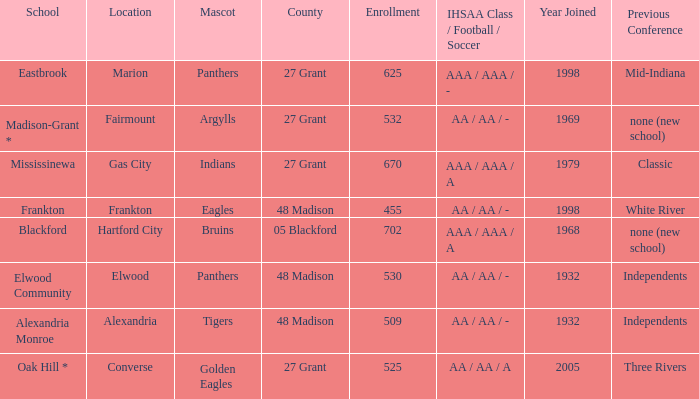What is teh ihsaa class/football/soccer when the location is alexandria? AA / AA / -. 